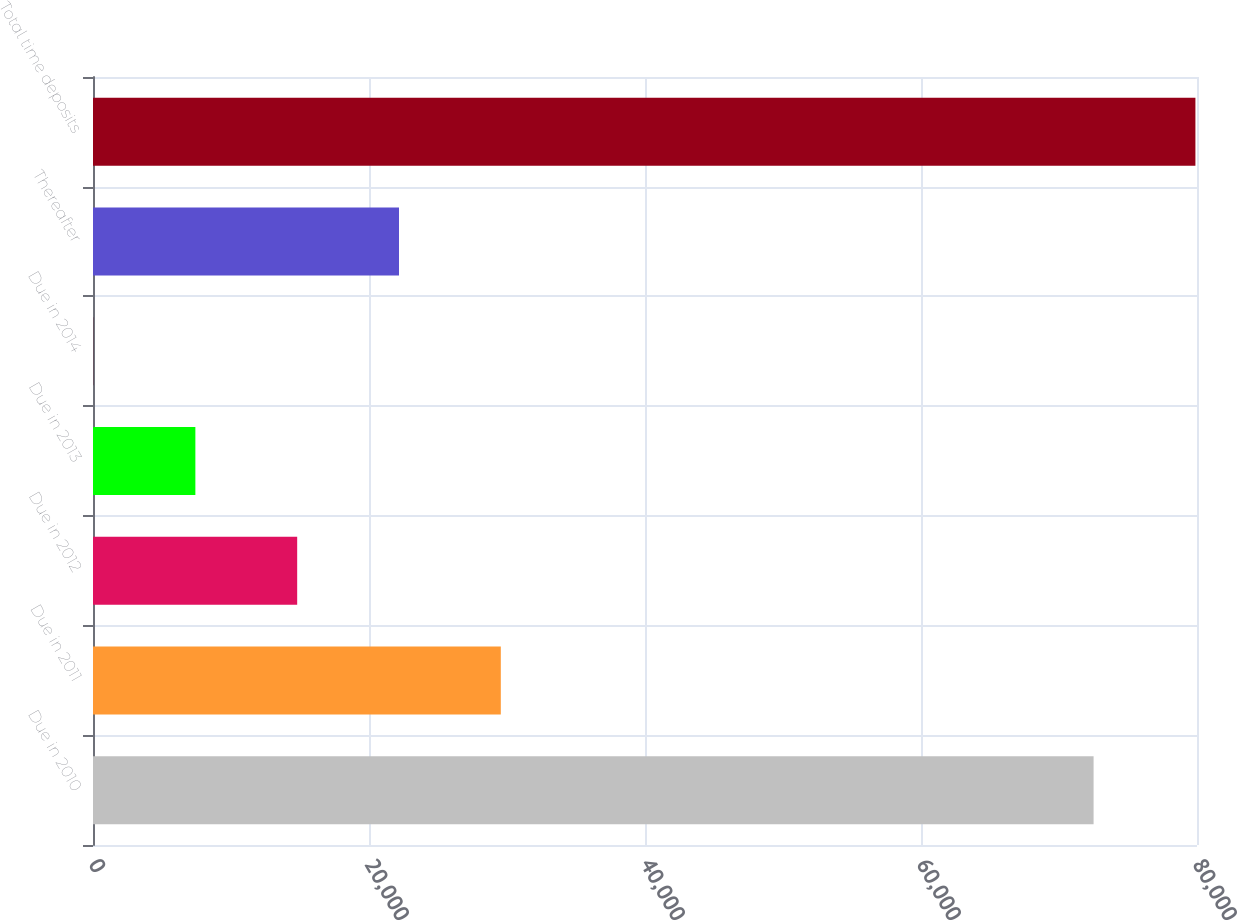<chart> <loc_0><loc_0><loc_500><loc_500><bar_chart><fcel>Due in 2010<fcel>Due in 2011<fcel>Due in 2012<fcel>Due in 2013<fcel>Due in 2014<fcel>Thereafter<fcel>Total time deposits<nl><fcel>72507<fcel>29551.6<fcel>14795.8<fcel>7417.9<fcel>40<fcel>22173.7<fcel>79884.9<nl></chart> 